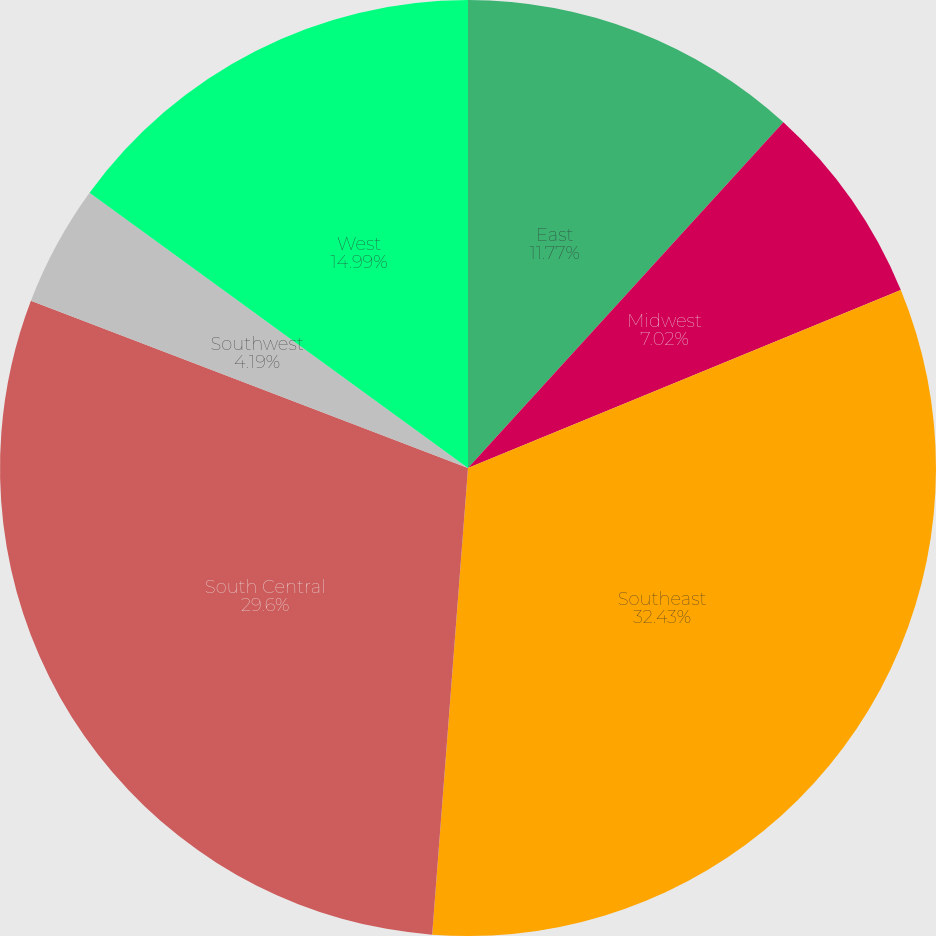Convert chart. <chart><loc_0><loc_0><loc_500><loc_500><pie_chart><fcel>East<fcel>Midwest<fcel>Southeast<fcel>South Central<fcel>Southwest<fcel>West<nl><fcel>11.77%<fcel>7.02%<fcel>32.43%<fcel>29.6%<fcel>4.19%<fcel>14.99%<nl></chart> 